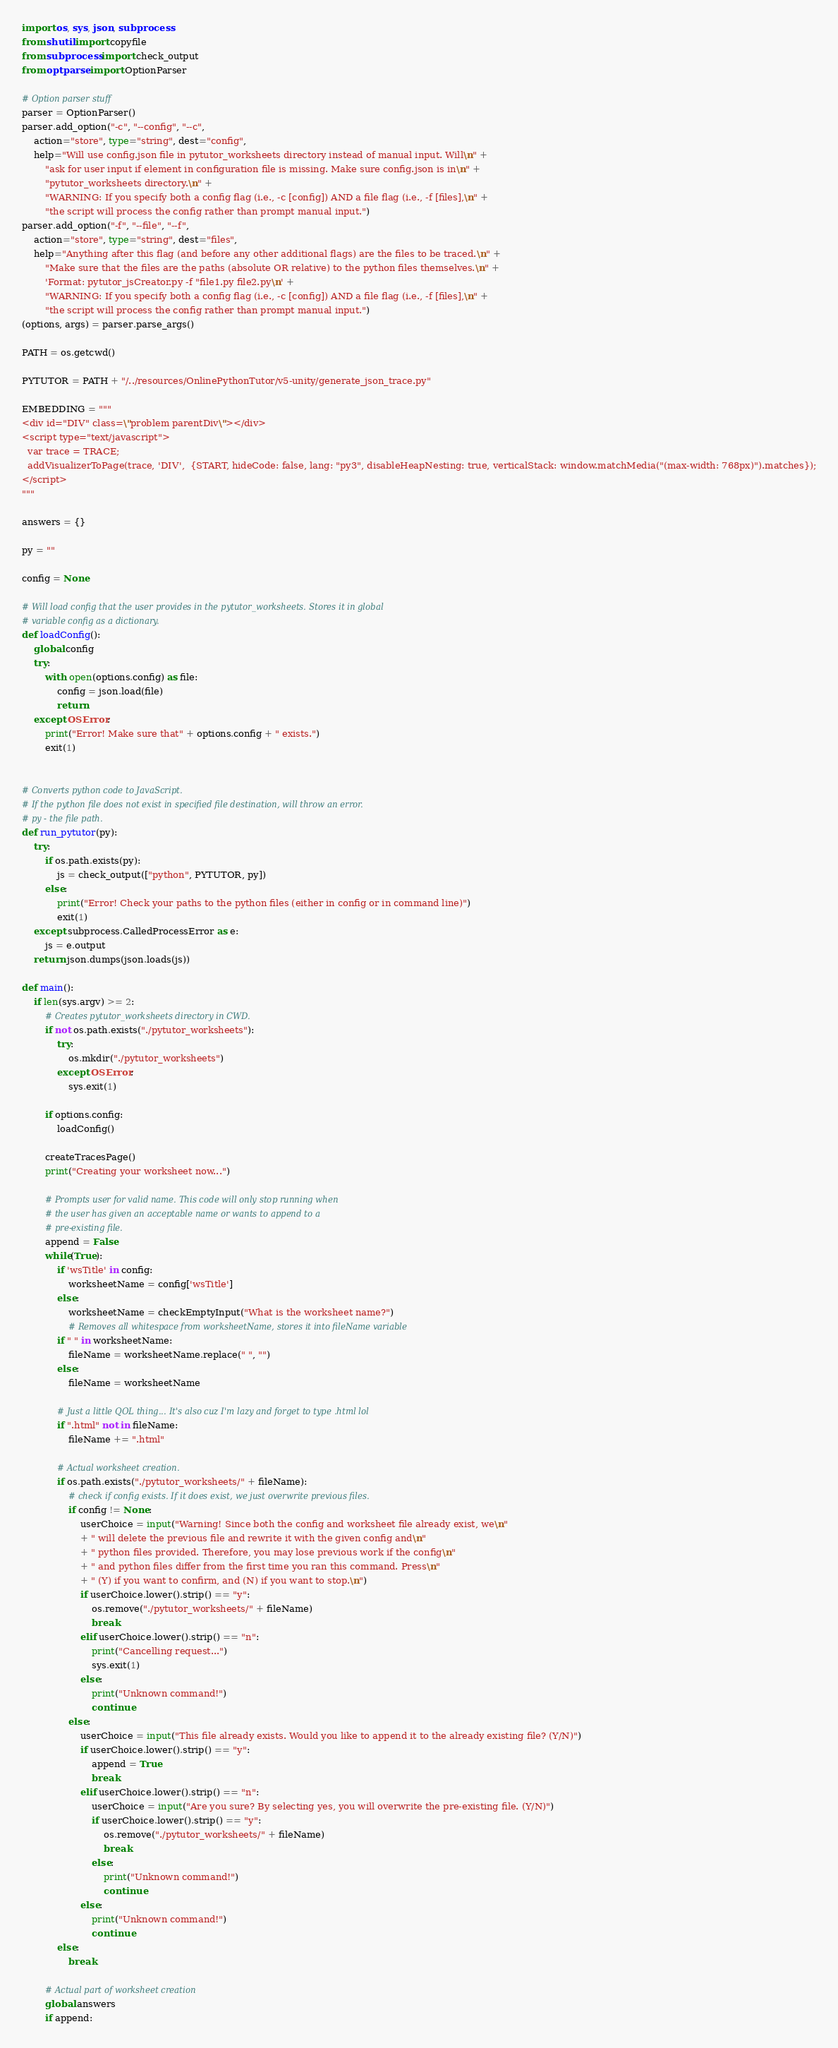<code> <loc_0><loc_0><loc_500><loc_500><_Python_>import os, sys, json, subprocess
from shutil import copyfile
from subprocess import check_output
from optparse import OptionParser

# Option parser stuff
parser = OptionParser()
parser.add_option("-c", "--config", "--c",
    action="store", type="string", dest="config",
    help="Will use config.json file in pytutor_worksheets directory instead of manual input. Will\n" +
        "ask for user input if element in configuration file is missing. Make sure config.json is in\n" +
        "pytutor_worksheets directory.\n" + 
        "WARNING: If you specify both a config flag (i.e., -c [config]) AND a file flag (i.e., -f [files],\n" +
        "the script will process the config rather than prompt manual input.")
parser.add_option("-f", "--file", "--f",
    action="store", type="string", dest="files",
    help="Anything after this flag (and before any other additional flags) are the files to be traced.\n" +
        "Make sure that the files are the paths (absolute OR relative) to the python files themselves.\n" +
        'Format: pytutor_jsCreator.py -f "file1.py file2.py\n' +
        "WARNING: If you specify both a config flag (i.e., -c [config]) AND a file flag (i.e., -f [files],\n" +
        "the script will process the config rather than prompt manual input.")
(options, args) = parser.parse_args()

PATH = os.getcwd()

PYTUTOR = PATH + "/../resources/OnlinePythonTutor/v5-unity/generate_json_trace.py"

EMBEDDING = """
<div id="DIV" class=\"problem parentDiv\"></div>
<script type="text/javascript">
  var trace = TRACE;
  addVisualizerToPage(trace, 'DIV',  {START, hideCode: false, lang: "py3", disableHeapNesting: true, verticalStack: window.matchMedia("(max-width: 768px)").matches});
</script>
"""

answers = {}

py = ""

config = None

# Will load config that the user provides in the pytutor_worksheets. Stores it in global
# variable config as a dictionary.
def loadConfig():
    global config
    try:
        with open(options.config) as file:
            config = json.load(file)
            return
    except OSError:
        print("Error! Make sure that" + options.config + " exists.")
        exit(1)
    

# Converts python code to JavaScript. 
# If the python file does not exist in specified file destination, will throw an error.
# py - the file path.
def run_pytutor(py):
    try:
        if os.path.exists(py):
            js = check_output(["python", PYTUTOR, py])
        else:
            print("Error! Check your paths to the python files (either in config or in command line)")
            exit(1)
    except subprocess.CalledProcessError as e:
        js = e.output
    return json.dumps(json.loads(js))

def main():
    if len(sys.argv) >= 2:
        # Creates pytutor_worksheets directory in CWD.
        if not os.path.exists("./pytutor_worksheets"):
            try:
                os.mkdir("./pytutor_worksheets")
            except OSError:
                sys.exit(1)
        
        if options.config:
            loadConfig()

        createTracesPage()
        print("Creating your worksheet now...")

        # Prompts user for valid name. This code will only stop running when
        # the user has given an acceptable name or wants to append to a 
        # pre-existing file.
        append = False
        while(True):
            if 'wsTitle' in config:
                worksheetName = config['wsTitle']
            else:
                worksheetName = checkEmptyInput("What is the worksheet name?")
                # Removes all whitespace from worksheetName, stores it into fileName variable
            if " " in worksheetName:
                fileName = worksheetName.replace(" ", "")
            else:
                fileName = worksheetName

            # Just a little QOL thing... It's also cuz I'm lazy and forget to type .html lol
            if ".html" not in fileName:
                fileName += ".html"

            # Actual worksheet creation.
            if os.path.exists("./pytutor_worksheets/" + fileName):
                # check if config exists. If it does exist, we just overwrite previous files.
                if config != None:
                    userChoice = input("Warning! Since both the config and worksheet file already exist, we\n"
                    + " will delete the previous file and rewrite it with the given config and\n"
                    + " python files provided. Therefore, you may lose previous work if the config\n"
                    + " and python files differ from the first time you ran this command. Press\n"
                    + " (Y) if you want to confirm, and (N) if you want to stop.\n")
                    if userChoice.lower().strip() == "y":
                        os.remove("./pytutor_worksheets/" + fileName)
                        break
                    elif userChoice.lower().strip() == "n":
                        print("Cancelling request...")
                        sys.exit(1)
                    else:
                        print("Unknown command!")
                        continue
                else:
                    userChoice = input("This file already exists. Would you like to append it to the already existing file? (Y/N)")
                    if userChoice.lower().strip() == "y":
                        append = True
                        break
                    elif userChoice.lower().strip() == "n":
                        userChoice = input("Are you sure? By selecting yes, you will overwrite the pre-existing file. (Y/N)")
                        if userChoice.lower().strip() == "y":
                            os.remove("./pytutor_worksheets/" + fileName)
                            break
                        else:
                            print("Unknown command!")
                            continue
                    else:
                        print("Unknown command!")
                        continue
            else:
                break
        
        # Actual part of worksheet creation
        global answers
        if append:</code> 